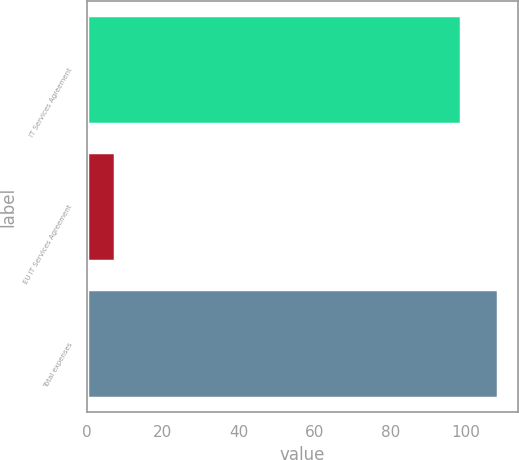Convert chart to OTSL. <chart><loc_0><loc_0><loc_500><loc_500><bar_chart><fcel>IT Services Agreement<fcel>EU IT Services Agreement<fcel>Total expenses<nl><fcel>98.5<fcel>7.5<fcel>108.35<nl></chart> 